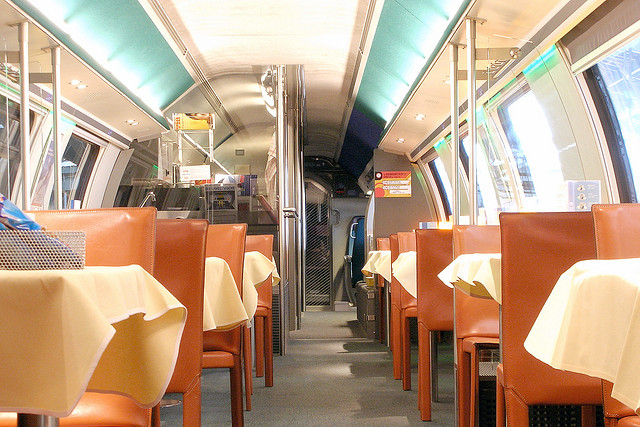<image>Is anyone sitting at a table? No, there is no one sitting at the table. Is anyone sitting at a table? There is no one sitting at a table in the image. 